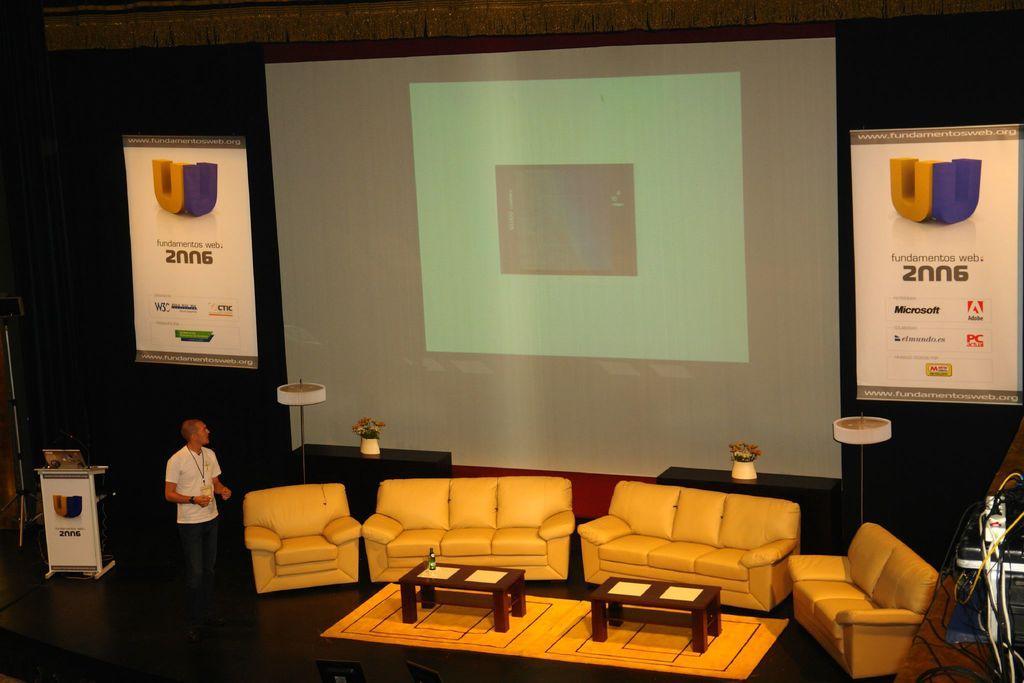How would you summarize this image in a sentence or two? I can see a man is standing on the floor, a projector screen, a few couches and tables on the floor. 